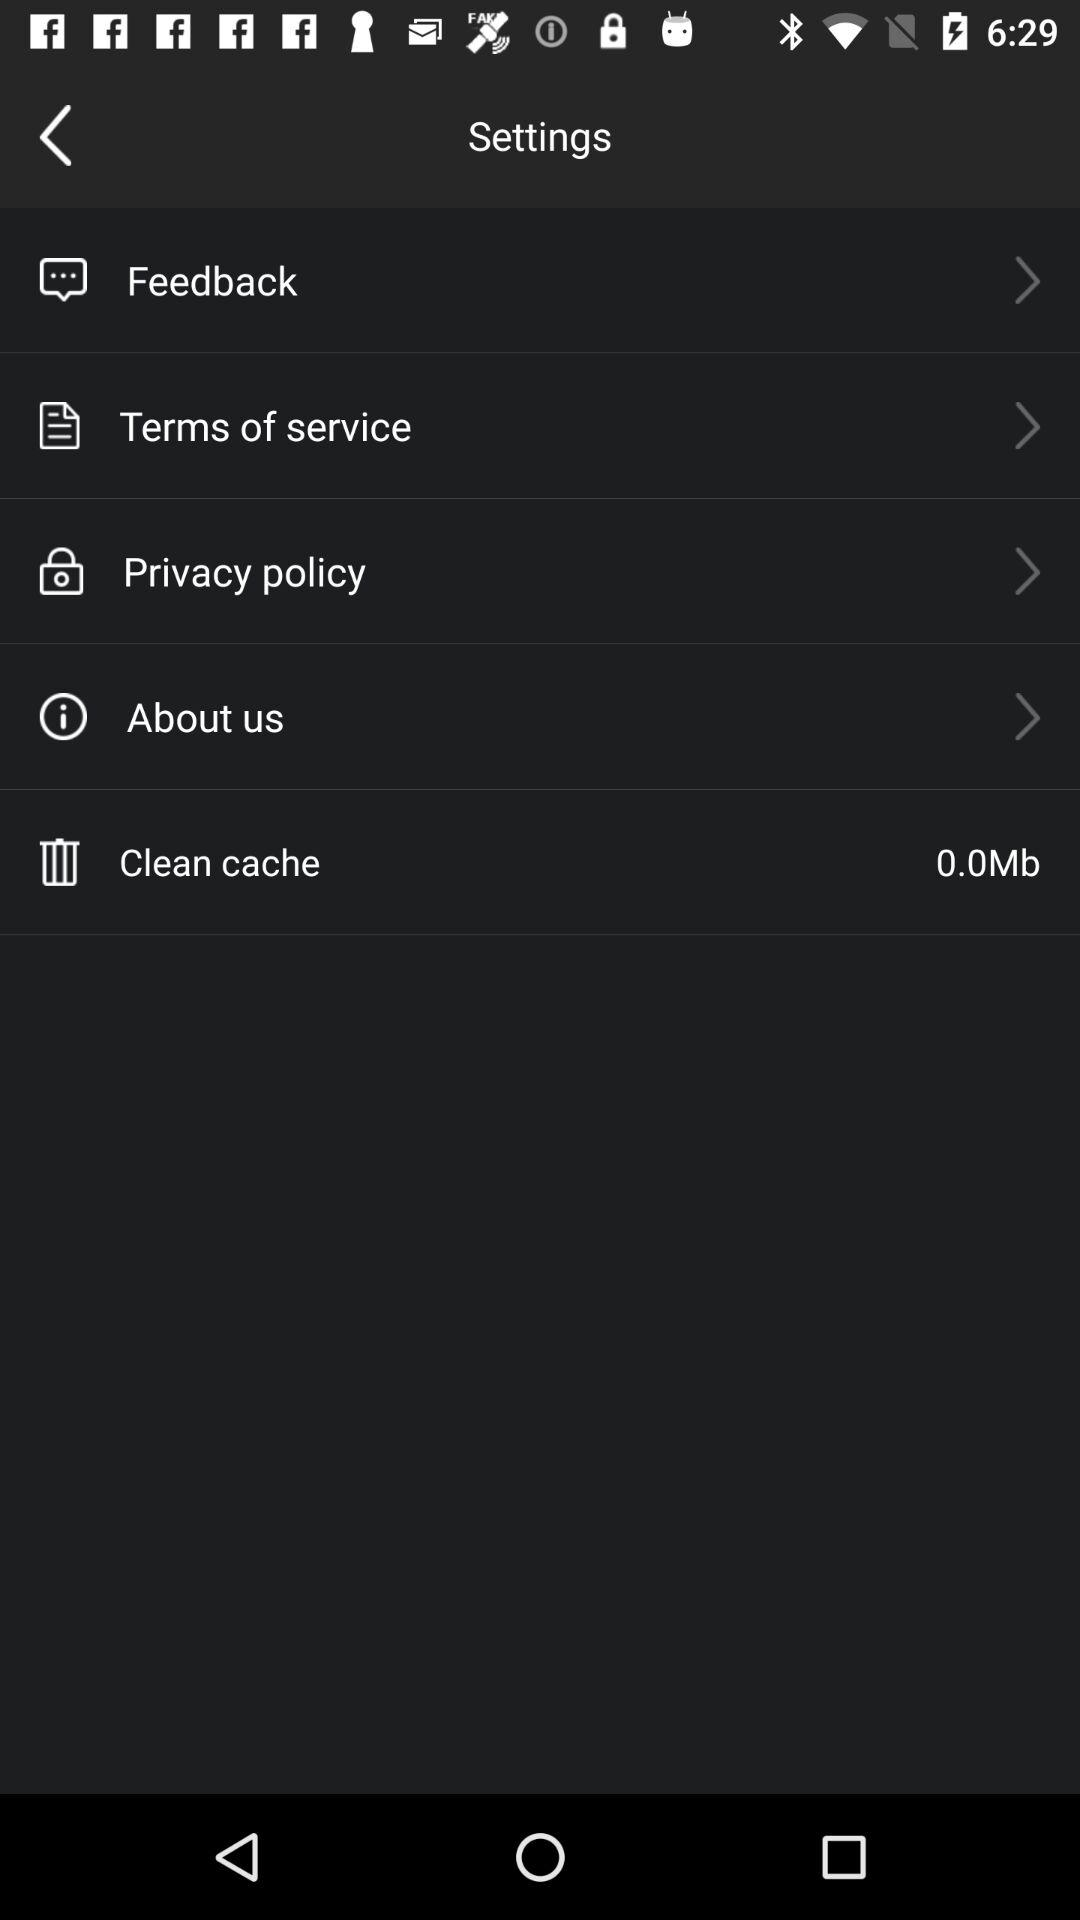How much cache can be cleaned? The cache that can be cleaned is 0.00 Mb. 